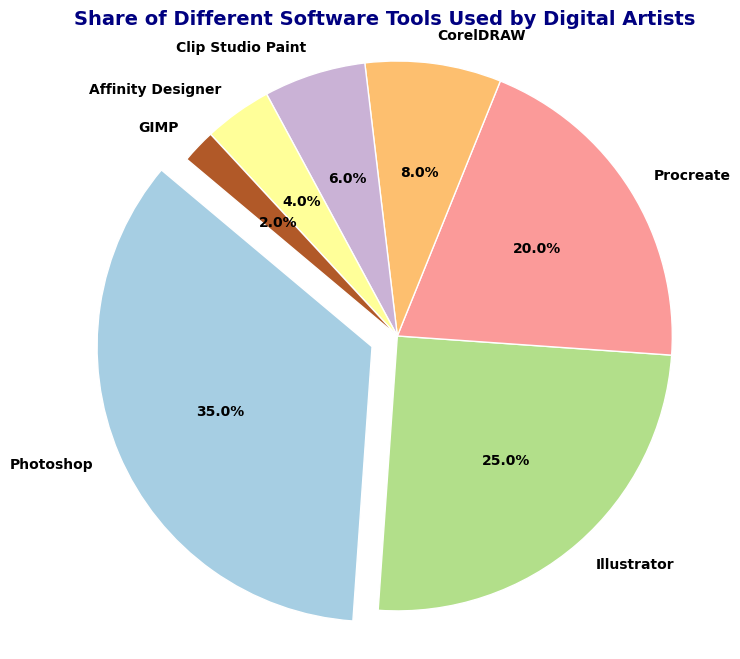What's the software tool with the highest share among digital artists? The pie chart shows that Photoshop has the largest segment highlighted by the explosion effect and takes the biggest portion of the pie chart.
Answer: Photoshop What is the combined share of Illustrator and Procreate? Illustrator has a share of 25% and Procreate has a share of 20%. Adding these two together gives 25% + 20% = 45%.
Answer: 45% Which software tools have a share lower than 10%? By looking at the pie chart, the segments for CorelDRAW, Clip Studio Paint, Affinity Designer, and GIMP are smaller than 10%.
Answer: CorelDRAW, Clip Studio Paint, Affinity Designer, GIMP How much larger is Photoshop's share compared to CorelDRAW's share? Photoshop's share is 35% and CorelDRAW's share is 8%. Subtracting CorelDRAW's share from Photoshop's share gives 35% - 8% = 27%.
Answer: 27% What is the total share of the software tools that have a share less than 10%? CorelDRAW, Clip Studio Paint, Affinity Designer, and GIMP have shares of 8%, 6%, 4%, and 2% respectively. Adding these together gives 8% + 6% + 4% + 2% = 20%.
Answer: 20% Which software tool has the smallest share among digital artists? The pie chart shows that GIMP has the smallest segment in the pie chart.
Answer: GIMP How much does Affinity Designer's share contribute to the total share? Affinity Designer has a share of 4%. This directly answers the contribution proportion of Affinity Designer in comparison to the total share.
Answer: 4% Compare the shares of Clip Studio Paint and Affinity Designer in terms of their relationship. Which one is larger and by how much? Clip Studio Paint has a share of 6%, and Affinity Designer has a share of 4%. The difference between them is 6% - 4% = 2%, with Clip Studio Paint being larger.
Answer: Clip Studio Paint by 2% What is the share difference between Illustrator and Procreate? Illustrator has a share of 25%, and Procreate has a share of 20%. The difference between the two shares is 25% - 20% = 5%.
Answer: 5% 